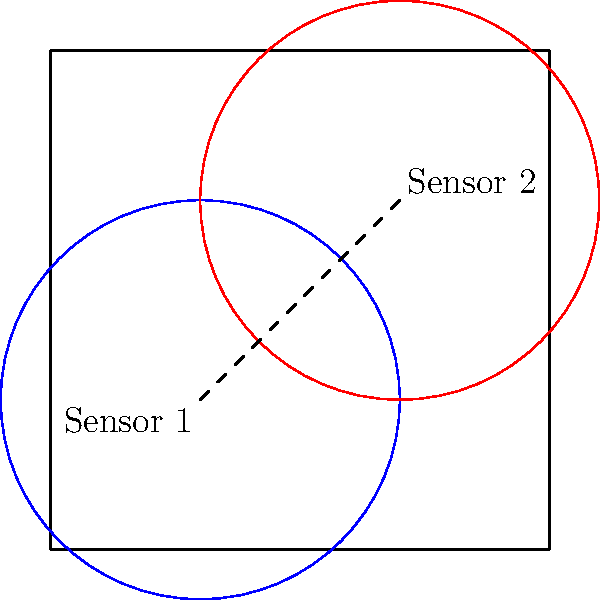In a large rectangular warehouse measuring 10m x 10m, two motion sensors are installed at positions (3m, 3m) and (7m, 7m). Each sensor has a circular coverage area with a radius of 4m. Calculate the total area covered by both sensors, taking into account the overlapping region. To solve this problem, we need to follow these steps:

1. Calculate the area of each sensor's coverage:
   Area of one sensor = $\pi r^2 = \pi (4m)^2 = 16\pi$ m²

2. Calculate the total area of both sensors without considering overlap:
   Total area without overlap = $2 * 16\pi = 32\pi$ m²

3. Calculate the distance between the sensors:
   Distance = $\sqrt{(7-3)^2 + (7-3)^2} = \sqrt{4^2 + 4^2} = 4\sqrt{2}$ m

4. Calculate the area of overlap using the formula for the area of intersection of two circles:
   $A_{overlap} = 2r^2 \arccos(\frac{d}{2r}) - d\sqrt{r^2 - \frac{d^2}{4}}$
   Where $r = 4m$ and $d = 4\sqrt{2}m$

   $A_{overlap} = 2(4^2) \arccos(\frac{4\sqrt{2}}{2(4)}) - 4\sqrt{2}\sqrt{4^2 - \frac{(4\sqrt{2})^2}{4}}$
   $= 32 \arccos(\frac{\sqrt{2}}{2}) - 4\sqrt{2}\sqrt{16 - 8}$
   $= 32 \arccos(\frac{\sqrt{2}}{2}) - 4\sqrt{2}\sqrt{8}$
   $= 32 \arccos(\frac{\sqrt{2}}{2}) - 16$

5. Calculate the total area covered by subtracting the overlap from the sum of individual areas:
   Total covered area = $32\pi - (32 \arccos(\frac{\sqrt{2}}{2}) - 16)$
   $= 32\pi - 32 \arccos(\frac{\sqrt{2}}{2}) + 16$
Answer: $32\pi - 32 \arccos(\frac{\sqrt{2}}{2}) + 16$ m² 